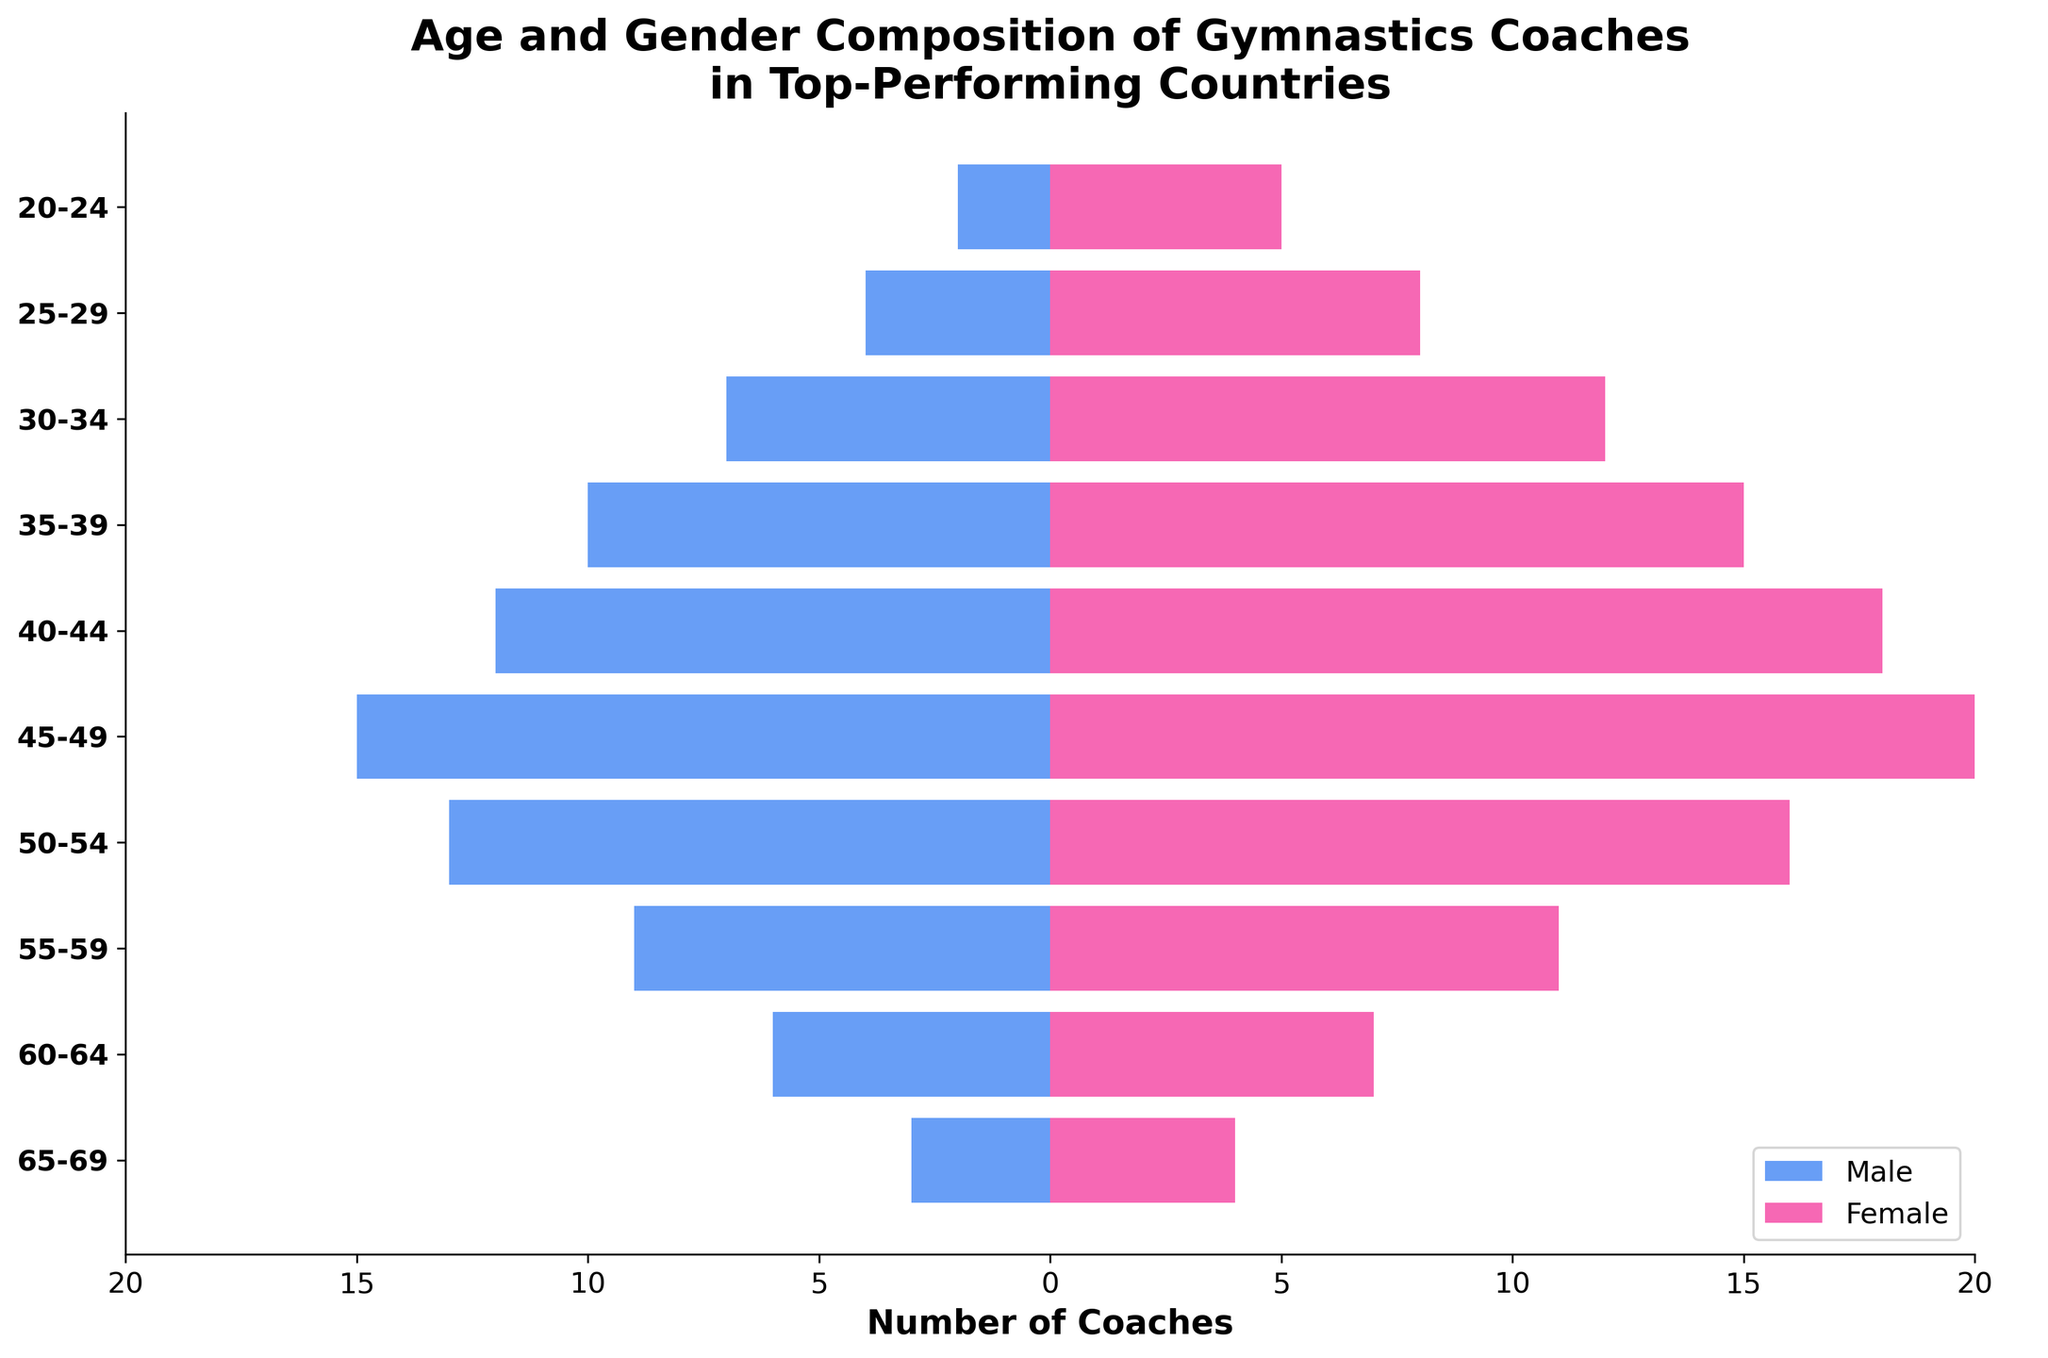What's the title of the plot? The title of the plot is displayed at the top and reads: "Age and Gender Composition of Gymnastics Coaches in Top-Performing Countries".
Answer: Age and Gender Composition of Gymnastics Coaches in Top-Performing Countries What is the age group with the highest number of female coaches? The age group with the highest number of female coaches can be identified by the longest pink bar. The longest pink bar corresponds to the 45-49 age group, with 20 female coaches.
Answer: 45-49 How many female coaches fall within the 30-34 age group? The number of female coaches within the 30-34 age group can be found by looking at the length of the pink bar for that age group. It is labeled as having 12 female coaches.
Answer: 12 What is the difference in the number of male coaches between the 40-44 and 50-54 age groups? The number of male coaches in the 40-44 age group is 12, and in the 50-54 age group it is 13. The difference between them is \(13 - 12 = 1\).
Answer: 1 Which age group has an equal number of male and female coaches? By comparing the lengths of the pink and blue bars for each age group, it is evident that no age group has an equal number of male and female coaches.
Answer: None Compare the number of male coaches in the 20-24 age group with the number of female coaches in the same group. Which is higher? The number of male coaches in the 20-24 age group is 2, while the number of female coaches in the same group is 5. 5 is greater than 2, so there are more female coaches in this age group.
Answer: Female What is the total number of coaches (both male and female) in the 35-39 age group? The total number of coaches in the 35-39 age group can be found by adding the number of male coaches (10) and female coaches (15). Thus, \(10 + 15 = 25\).
Answer: 25 How many age groups have more female coaches than male coaches? By inspecting the bars, there are more female coaches than male in all age groups except the 50-54 age group.
Answer: 9 What is the total number of male coaches in all age groups combined? Adding the values for male coaches across all age groups: \(2 + 4 + 7 + 10 + 12 + 15 + 13 + 9 + 6 + 3 = 81\).
Answer: 81 What is the age range for the oldest group of coaches? The age range of the oldest group of coaches is labeled as 65-69, which is the topmost group in the plot.
Answer: 65-69 